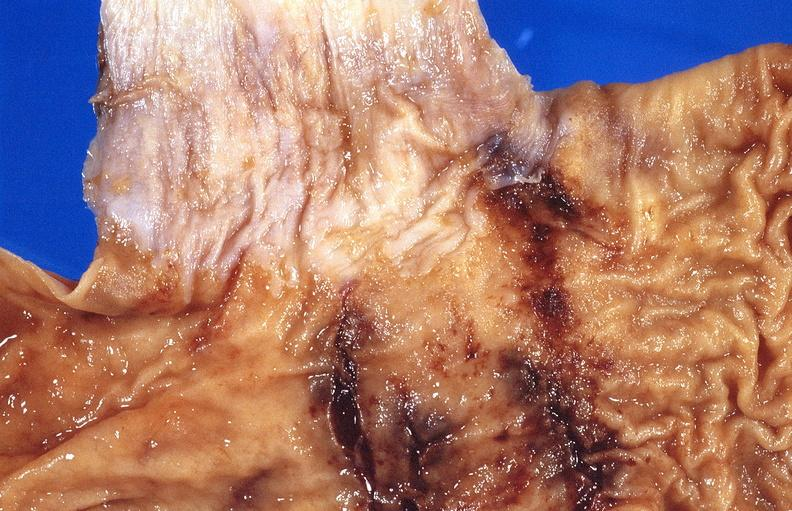does this image show stomach, cushing ulcers?
Answer the question using a single word or phrase. Yes 